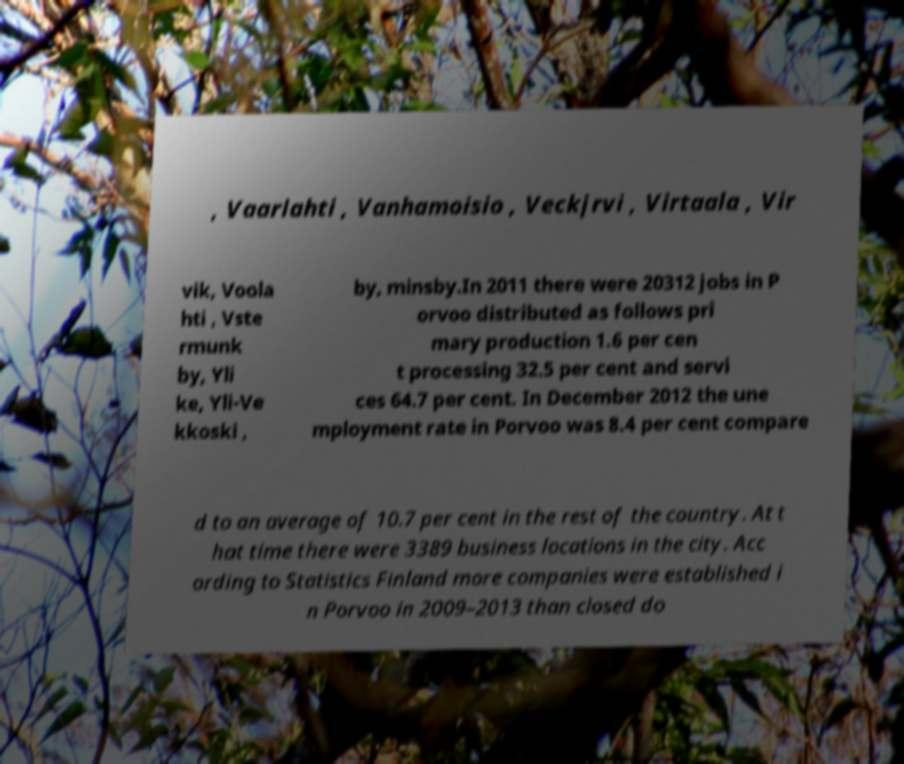Could you assist in decoding the text presented in this image and type it out clearly? , Vaarlahti , Vanhamoisio , Veckjrvi , Virtaala , Vir vik, Voola hti , Vste rmunk by, Yli ke, Yli-Ve kkoski , by, minsby.In 2011 there were 20312 jobs in P orvoo distributed as follows pri mary production 1.6 per cen t processing 32.5 per cent and servi ces 64.7 per cent. In December 2012 the une mployment rate in Porvoo was 8.4 per cent compare d to an average of 10.7 per cent in the rest of the country. At t hat time there were 3389 business locations in the city. Acc ording to Statistics Finland more companies were established i n Porvoo in 2009–2013 than closed do 